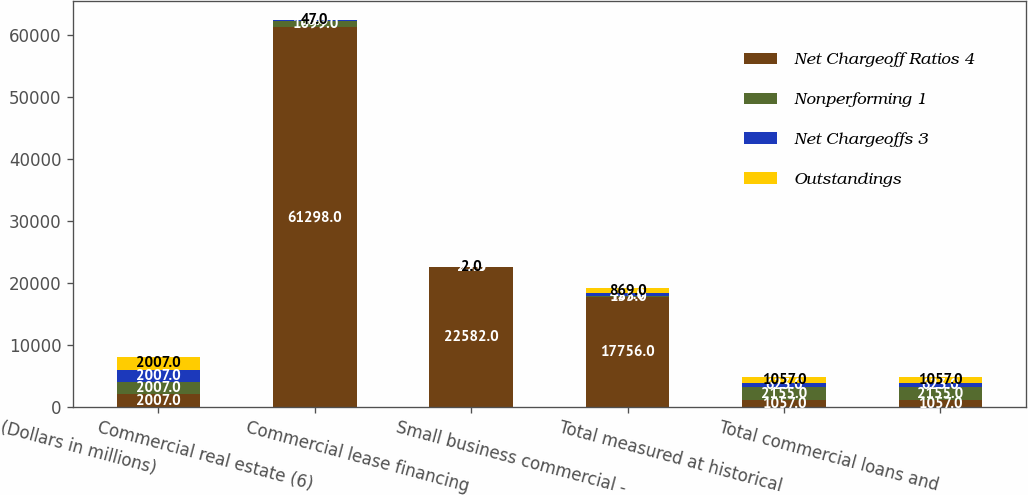Convert chart to OTSL. <chart><loc_0><loc_0><loc_500><loc_500><stacked_bar_chart><ecel><fcel>(Dollars in millions)<fcel>Commercial real estate (6)<fcel>Commercial lease financing<fcel>Small business commercial -<fcel>Total measured at historical<fcel>Total commercial loans and<nl><fcel>Net Chargeoff Ratios 4<fcel>2007<fcel>61298<fcel>22582<fcel>17756<fcel>1057<fcel>1057<nl><fcel>Nonperforming 1<fcel>2007<fcel>1099<fcel>33<fcel>135<fcel>2155<fcel>2155<nl><fcel>Net Chargeoffs 3<fcel>2007<fcel>36<fcel>25<fcel>427<fcel>623<fcel>623<nl><fcel>Outstandings<fcel>2007<fcel>47<fcel>2<fcel>869<fcel>1057<fcel>1057<nl></chart> 